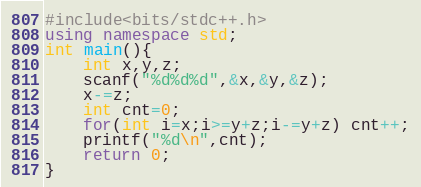<code> <loc_0><loc_0><loc_500><loc_500><_C++_>#include<bits/stdc++.h>
using namespace std;
int main(){
    int x,y,z;
    scanf("%d%d%d",&x,&y,&z);
    x-=z;
    int cnt=0;
    for(int i=x;i>=y+z;i-=y+z) cnt++;
    printf("%d\n",cnt);
    return 0;
}

</code> 